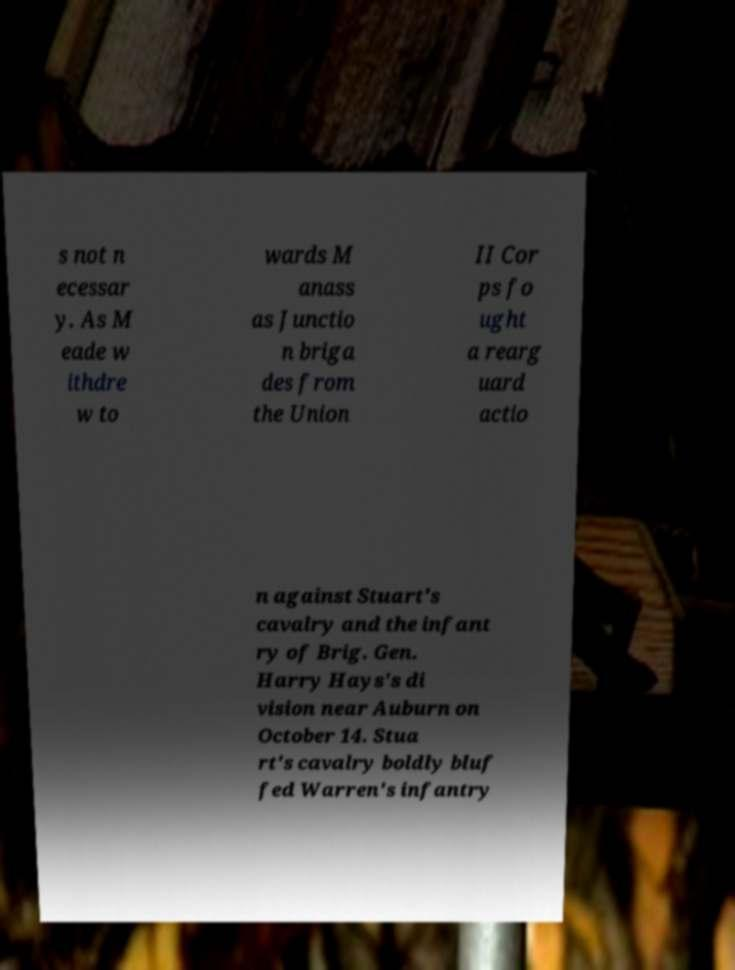What messages or text are displayed in this image? I need them in a readable, typed format. s not n ecessar y. As M eade w ithdre w to wards M anass as Junctio n briga des from the Union II Cor ps fo ught a rearg uard actio n against Stuart's cavalry and the infant ry of Brig. Gen. Harry Hays's di vision near Auburn on October 14. Stua rt's cavalry boldly bluf fed Warren's infantry 